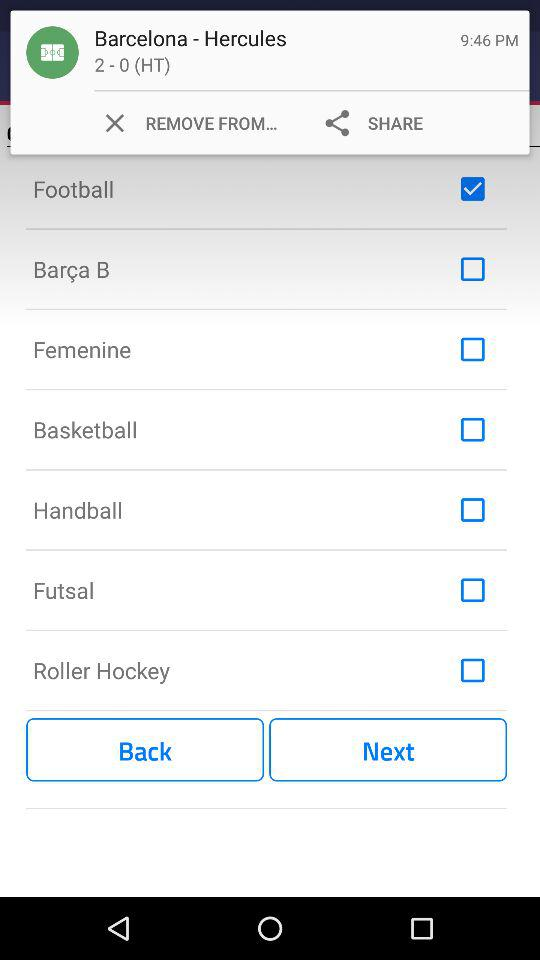What is the status of "Futsal"? The status is "off". 